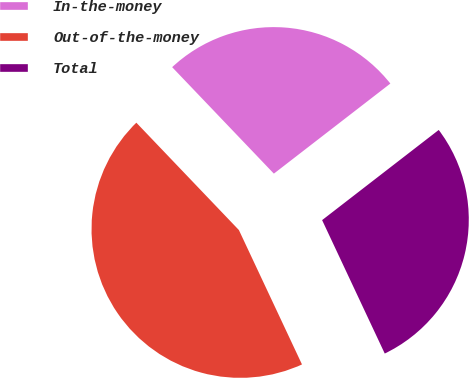<chart> <loc_0><loc_0><loc_500><loc_500><pie_chart><fcel>In-the-money<fcel>Out-of-the-money<fcel>Total<nl><fcel>26.66%<fcel>44.85%<fcel>28.49%<nl></chart> 